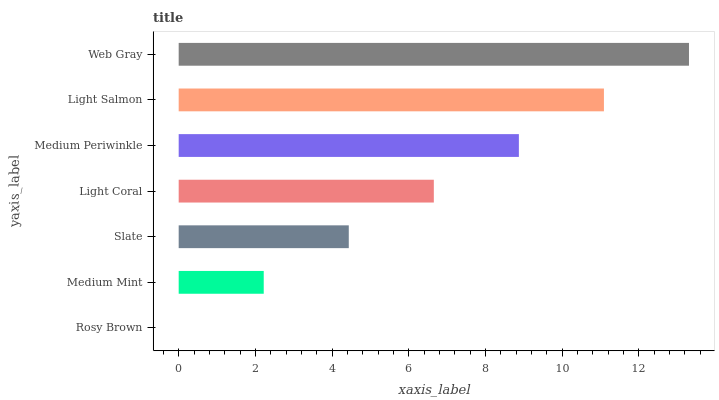Is Rosy Brown the minimum?
Answer yes or no. Yes. Is Web Gray the maximum?
Answer yes or no. Yes. Is Medium Mint the minimum?
Answer yes or no. No. Is Medium Mint the maximum?
Answer yes or no. No. Is Medium Mint greater than Rosy Brown?
Answer yes or no. Yes. Is Rosy Brown less than Medium Mint?
Answer yes or no. Yes. Is Rosy Brown greater than Medium Mint?
Answer yes or no. No. Is Medium Mint less than Rosy Brown?
Answer yes or no. No. Is Light Coral the high median?
Answer yes or no. Yes. Is Light Coral the low median?
Answer yes or no. Yes. Is Slate the high median?
Answer yes or no. No. Is Slate the low median?
Answer yes or no. No. 